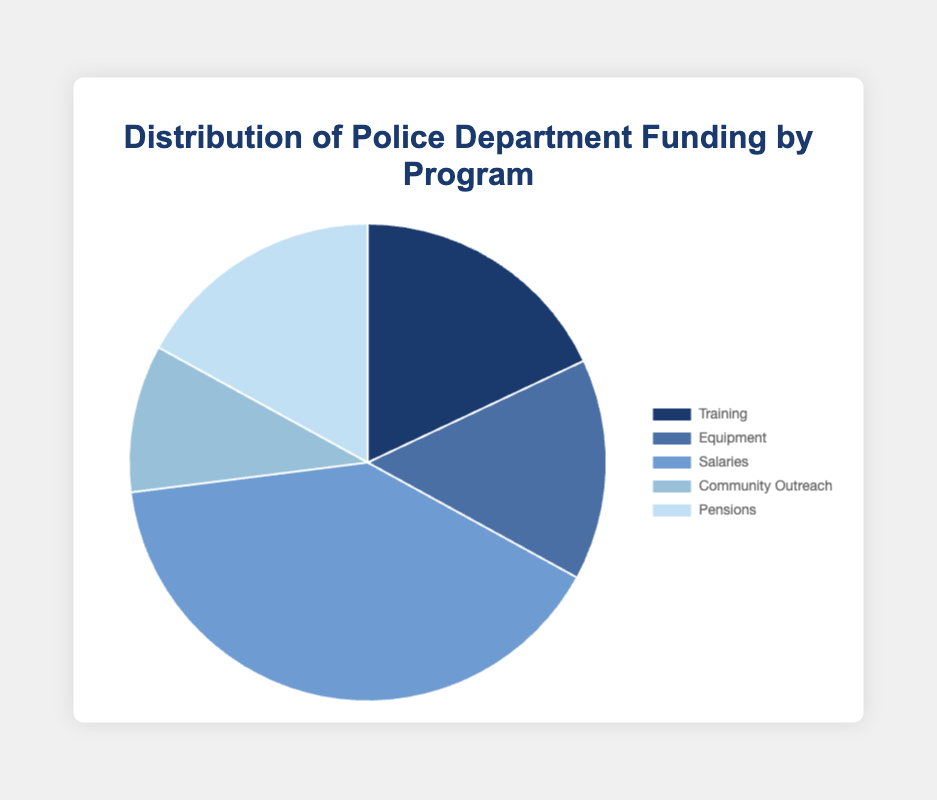Which program receives the highest percentage of funding? The pie chart shows the distribution percentages, and 'Salaries' has the highest value at 40%.
Answer: Salaries What percentage of the funding is allocated to Training and Pensions combined? Sum the percentages for Training (18%) and Pensions (17%) to get the total. So, 18 + 17 = 35%.
Answer: 35% Is the percentage of funding for Community Outreach less than Equipment? Compare the percentages for Community Outreach (10%) and Equipment (15%). Community Outreach has a lower percentage.
Answer: Yes Which two programs combined receive a greater percentage of funding than Salaries alone? Check combinations whose sum is greater than Salaries (40%). Training (18%) + Pensions (17%) = 35%, Training (18%) + Equipment (15%) = 33%, Equipment (15%) + Pensions (17%) = 32%, but Training (18%) + Equipment (15%) + Community Outreach (10%) = 43% > 40%.
Answer: Training and Equipment What is the average percentage of funding allocated to each program? There are five programs. Sum the percentages (18 + 15 + 40 + 10 + 17 = 100) and then divide by the number of programs (5). So, 100/5 = 20%.
Answer: 20% How much more funding (as a percentage) does Salaries receive compared to Training? Subtract the percentage for Training (18%) from Salaries (40%) to get the difference. So, 40 - 18 = 22%.
Answer: 22% What color is used to represent the Community Outreach program? The visual information shows that 'Community Outreach' is represented by the lightest shade in the pie chart, which is light blue.
Answer: Light blue If the funding for Equipment is increased by 5%, what would be the new percentage for Equipment? Add 5% to the current Equipment funding (15%). So, the new percentage is 15 + 5 = 20%.
Answer: 20% Which program's funding is closest to the average funding percentage? The average percentage is 20%. Compare each program's funding to this. Salaries (40%), Equipment (15%), Training (18%), Community Outreach (10%), Pensions (17%). The closest is Training (18%) and Pensions (17%)
Answer: Training and Pensions 